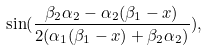Convert formula to latex. <formula><loc_0><loc_0><loc_500><loc_500>\sin ( \frac { \beta _ { 2 } \alpha _ { 2 } - \alpha _ { 2 } ( \beta _ { 1 } - x ) } { 2 ( \alpha _ { 1 } ( \beta _ { 1 } - x ) + \beta _ { 2 } \alpha _ { 2 } ) } ) ,</formula> 